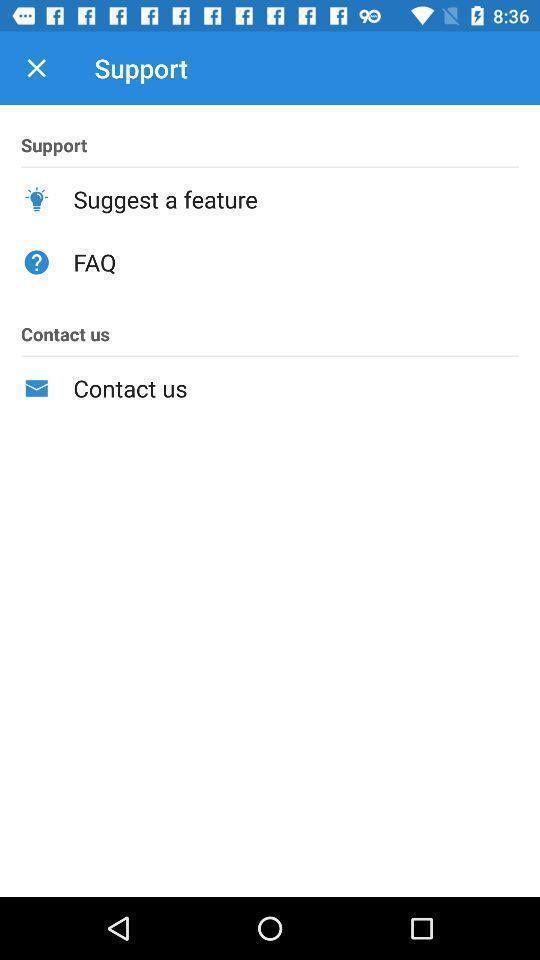Tell me about the visual elements in this screen capture. Support page of a calling app. 